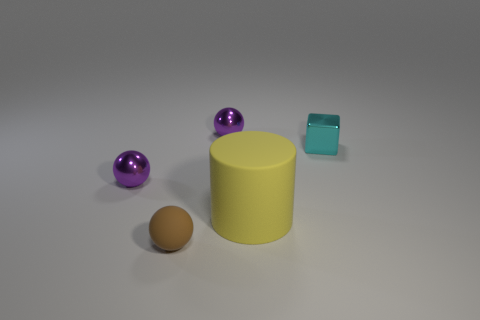What is the shape of the thing in front of the large object?
Your answer should be compact. Sphere. Is the shape of the matte object that is in front of the large rubber cylinder the same as the purple thing behind the small block?
Ensure brevity in your answer.  Yes. What is the shape of the purple shiny object in front of the tiny object right of the cylinder?
Offer a very short reply. Sphere. Is the material of the purple sphere on the right side of the tiny brown rubber sphere the same as the cube?
Provide a short and direct response. Yes. Are there the same number of tiny things that are to the right of the matte cylinder and yellow rubber things on the left side of the brown matte sphere?
Your answer should be compact. No. There is a rubber object left of the big yellow cylinder; what number of big yellow rubber things are behind it?
Give a very brief answer. 1. There is a object that is in front of the rubber cylinder; does it have the same color as the small ball that is on the right side of the small brown rubber ball?
Your answer should be compact. No. What is the material of the brown sphere that is the same size as the metallic block?
Offer a very short reply. Rubber. What is the shape of the metal thing that is right of the small ball that is behind the purple metal ball on the left side of the small rubber ball?
Ensure brevity in your answer.  Cube. What shape is the brown object that is the same size as the cyan metallic thing?
Ensure brevity in your answer.  Sphere. 